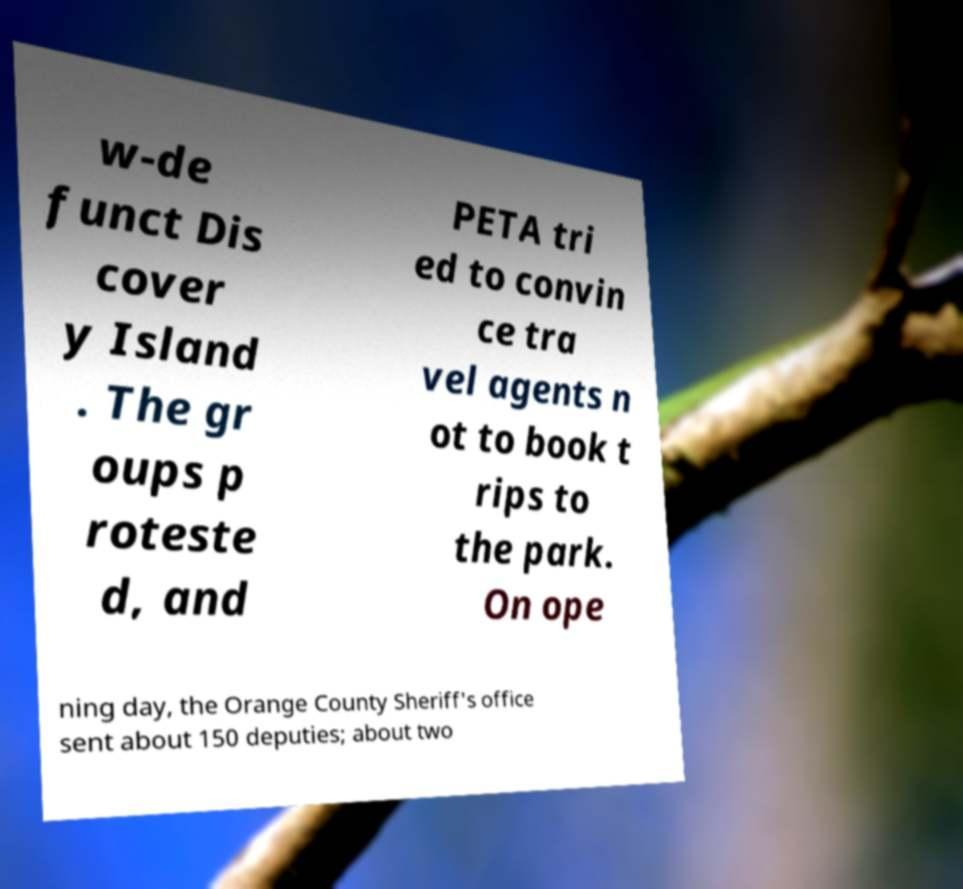Can you accurately transcribe the text from the provided image for me? w-de funct Dis cover y Island . The gr oups p roteste d, and PETA tri ed to convin ce tra vel agents n ot to book t rips to the park. On ope ning day, the Orange County Sheriff's office sent about 150 deputies; about two 